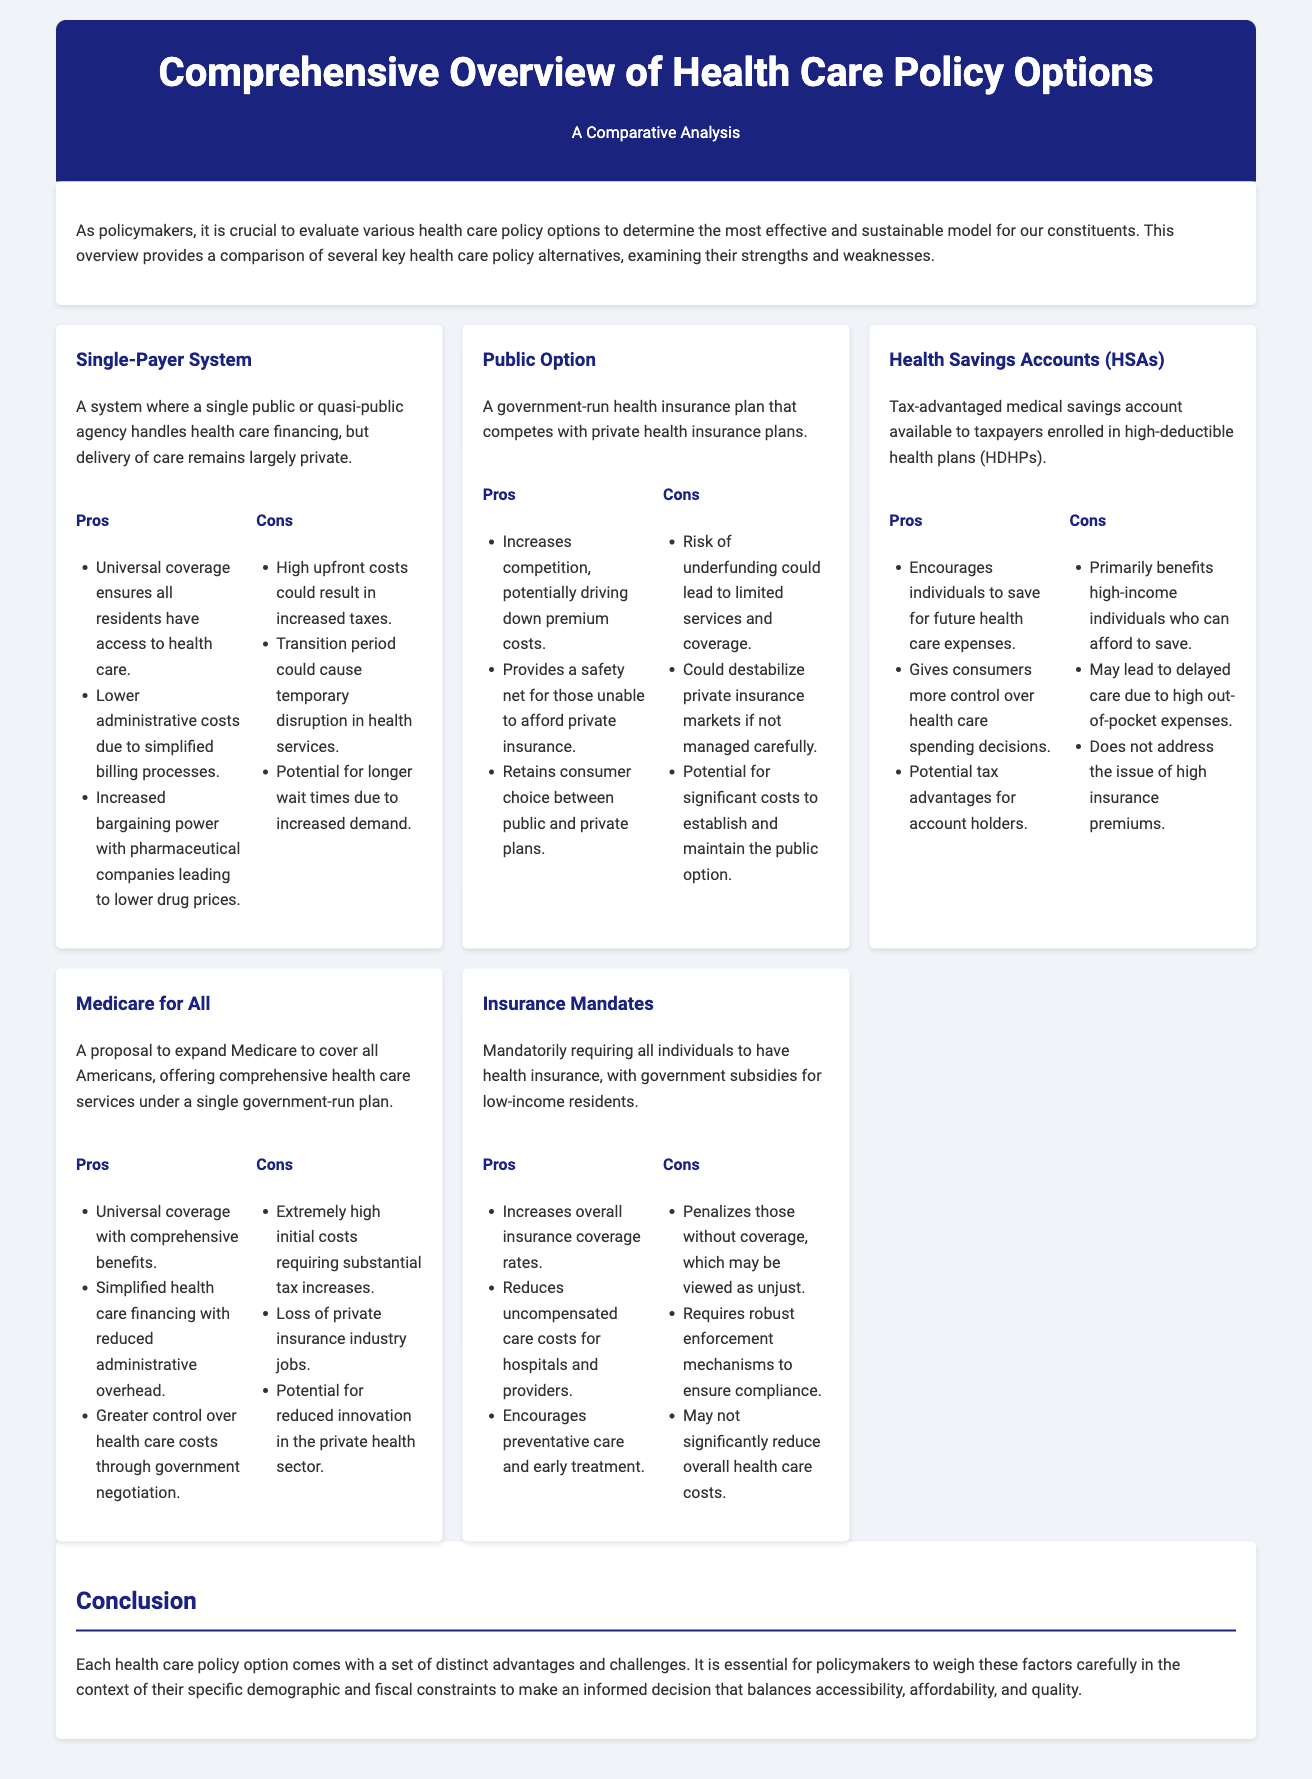what is the title of the document? The title of the document is the main heading presented in the header section.
Answer: Comprehensive Overview of Health Care Policy Options how many policy options are discussed? The document lists several health care policy options, and we count those listed in the policy section.
Answer: Five what is one pro of the Single-Payer System? The pros for the Single-Payer System are listed under its description.
Answer: Universal coverage ensures all residents have access to health care what are the cons of Medicare for All? The cons for Medicare for All are located in the corresponding section, focusing on potential drawbacks.
Answer: Extremely high initial costs requiring substantial tax increases which health care policy option provides a safety net for those unable to afford private insurance? The specific benefits of each policy option highlight different advantages, leading to this identification.
Answer: Public Option what is a potential risk associated with Insurance Mandates? Risks and challenges are discussed in the cons section for each policy, particularly for Insurance Mandates.
Answer: Penalizes those without coverage, which may be viewed as unjust what benefit do Health Savings Accounts offer to consumers? The benefits for Health Savings Accounts are outlined in the pros section, emphasizing consumer advantages.
Answer: Gives consumers more control over health care spending decisions what is stated about the transition period in the Single-Payer System? The challenges of transitioning to this system are discussed in its cons, shedding light on potential issues during implementation.
Answer: Transition period could cause temporary disruption in health services what is the conclusion about evaluating health care policy options? The conclusion provides overall insights into the analysis and decision-making process regarding the policy options.
Answer: It is essential for policymakers to weigh these factors carefully 